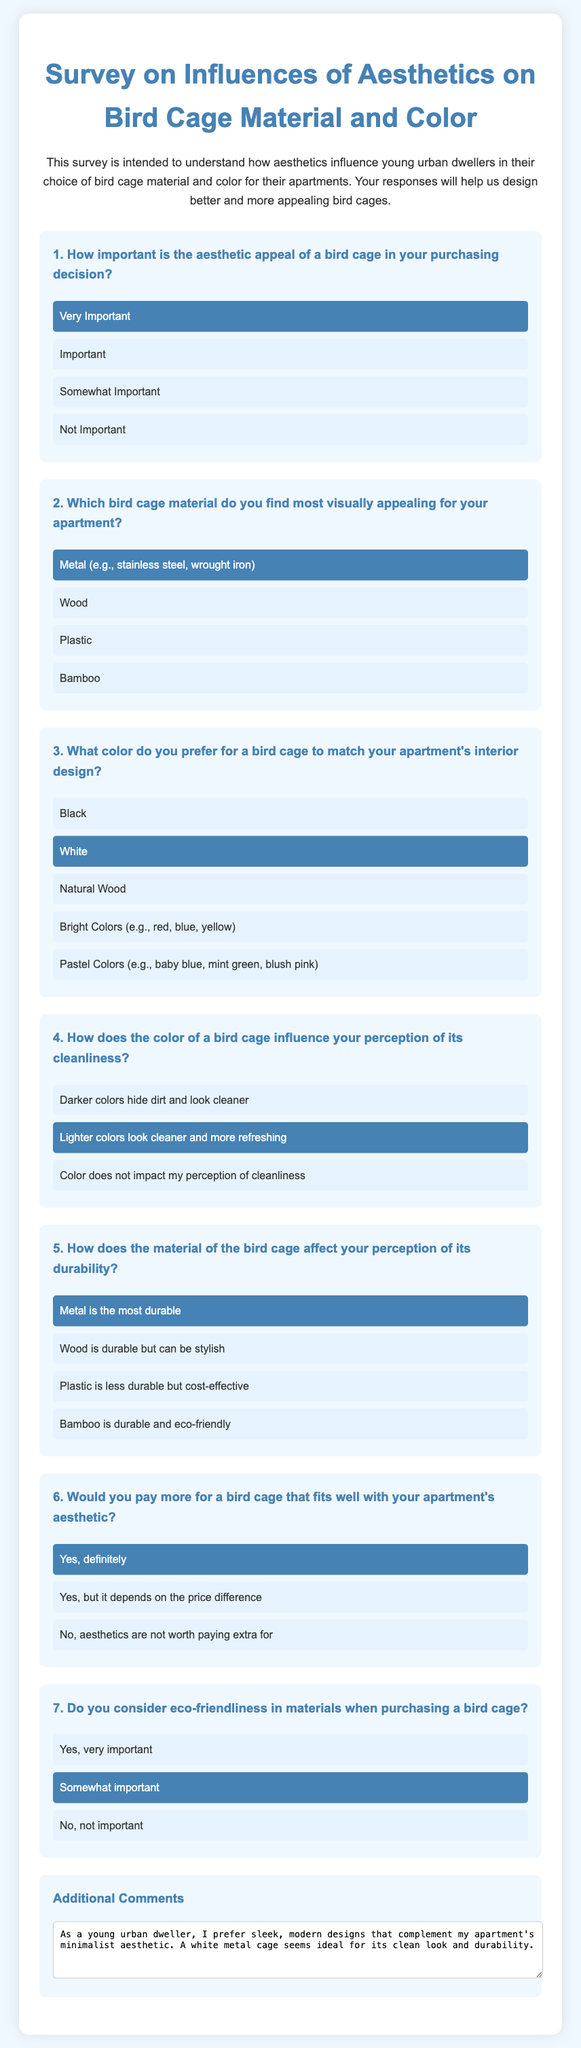What is the title of the survey? The title of the survey is displayed prominently at the top of the document.
Answer: Survey on Influences of Aesthetics on Bird Cage Material and Color How many options are provided for the importance of aesthetic appeal? The number of options is indicated in the section discussing the importance of aesthetic appeal.
Answer: Four Which material is considered the most visually appealing? The option marked as selected shows the material preferred by the respondent.
Answer: Metal (e.g., stainless steel, wrought iron) What color did the respondent select for the bird cage? The selected option in the survey indicates the preferred color for the bird cage.
Answer: White How does the respondent perceive the cleanliness of lighter colors? The response to how color influences cleanliness is reflected in the selected answer.
Answer: Lighter colors look cleaner and more refreshing What sentiment is expressed in the additional comments section? The additional comments contain the respondent's thoughts on aesthetics and functionality in their context.
Answer: A white metal cage seems ideal for its clean look and durability 